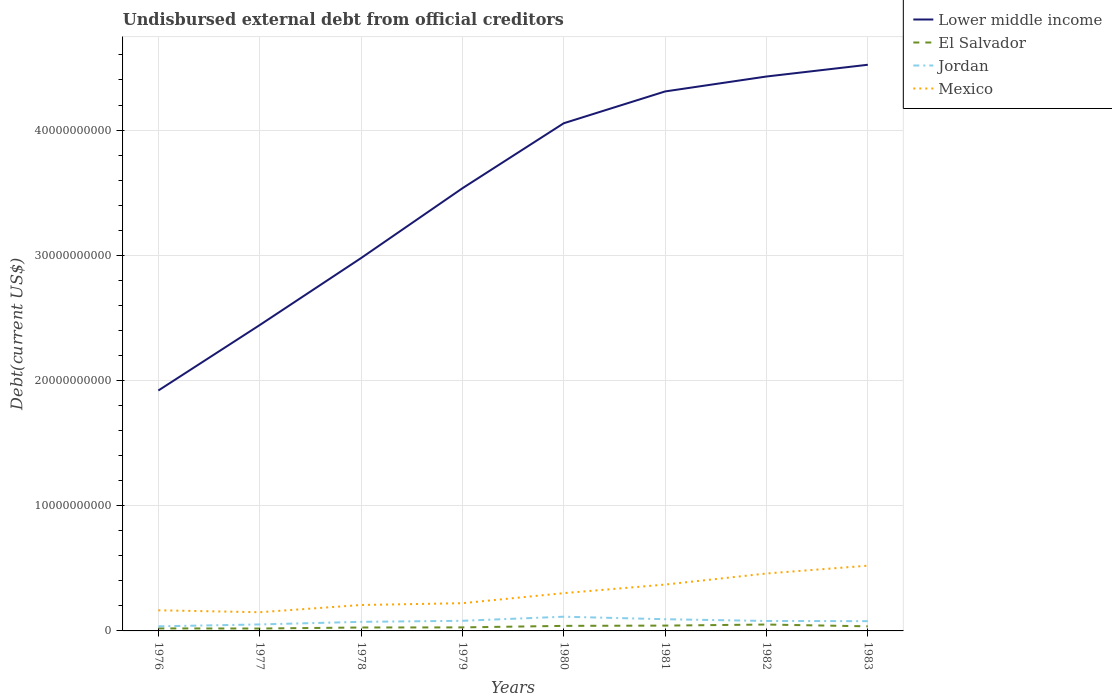How many different coloured lines are there?
Give a very brief answer. 4. Is the number of lines equal to the number of legend labels?
Offer a terse response. Yes. Across all years, what is the maximum total debt in Mexico?
Your answer should be compact. 1.49e+09. In which year was the total debt in Lower middle income maximum?
Ensure brevity in your answer.  1976. What is the total total debt in Lower middle income in the graph?
Make the answer very short. -1.09e+1. What is the difference between the highest and the second highest total debt in Lower middle income?
Provide a succinct answer. 2.60e+1. What is the difference between the highest and the lowest total debt in Lower middle income?
Your response must be concise. 5. How many lines are there?
Offer a terse response. 4. How many years are there in the graph?
Provide a succinct answer. 8. What is the difference between two consecutive major ticks on the Y-axis?
Ensure brevity in your answer.  1.00e+1. Does the graph contain grids?
Your answer should be very brief. Yes. How many legend labels are there?
Ensure brevity in your answer.  4. How are the legend labels stacked?
Offer a very short reply. Vertical. What is the title of the graph?
Give a very brief answer. Undisbursed external debt from official creditors. What is the label or title of the X-axis?
Offer a terse response. Years. What is the label or title of the Y-axis?
Keep it short and to the point. Debt(current US$). What is the Debt(current US$) in Lower middle income in 1976?
Provide a succinct answer. 1.92e+1. What is the Debt(current US$) in El Salvador in 1976?
Offer a terse response. 2.00e+08. What is the Debt(current US$) in Jordan in 1976?
Provide a succinct answer. 3.67e+08. What is the Debt(current US$) in Mexico in 1976?
Keep it short and to the point. 1.65e+09. What is the Debt(current US$) of Lower middle income in 1977?
Your answer should be very brief. 2.44e+1. What is the Debt(current US$) of El Salvador in 1977?
Provide a succinct answer. 1.92e+08. What is the Debt(current US$) in Jordan in 1977?
Provide a short and direct response. 5.18e+08. What is the Debt(current US$) in Mexico in 1977?
Ensure brevity in your answer.  1.49e+09. What is the Debt(current US$) of Lower middle income in 1978?
Your response must be concise. 2.98e+1. What is the Debt(current US$) of El Salvador in 1978?
Your response must be concise. 2.74e+08. What is the Debt(current US$) of Jordan in 1978?
Your response must be concise. 7.25e+08. What is the Debt(current US$) in Mexico in 1978?
Your answer should be compact. 2.07e+09. What is the Debt(current US$) in Lower middle income in 1979?
Provide a short and direct response. 3.54e+1. What is the Debt(current US$) of El Salvador in 1979?
Provide a short and direct response. 2.82e+08. What is the Debt(current US$) of Jordan in 1979?
Keep it short and to the point. 8.08e+08. What is the Debt(current US$) of Mexico in 1979?
Provide a short and direct response. 2.21e+09. What is the Debt(current US$) of Lower middle income in 1980?
Offer a terse response. 4.05e+1. What is the Debt(current US$) in El Salvador in 1980?
Offer a very short reply. 4.03e+08. What is the Debt(current US$) of Jordan in 1980?
Keep it short and to the point. 1.14e+09. What is the Debt(current US$) of Mexico in 1980?
Offer a terse response. 3.02e+09. What is the Debt(current US$) of Lower middle income in 1981?
Make the answer very short. 4.31e+1. What is the Debt(current US$) of El Salvador in 1981?
Provide a short and direct response. 4.26e+08. What is the Debt(current US$) in Jordan in 1981?
Your answer should be very brief. 9.35e+08. What is the Debt(current US$) in Mexico in 1981?
Ensure brevity in your answer.  3.70e+09. What is the Debt(current US$) in Lower middle income in 1982?
Give a very brief answer. 4.43e+1. What is the Debt(current US$) of El Salvador in 1982?
Your answer should be compact. 5.10e+08. What is the Debt(current US$) of Jordan in 1982?
Provide a short and direct response. 7.95e+08. What is the Debt(current US$) of Mexico in 1982?
Make the answer very short. 4.59e+09. What is the Debt(current US$) of Lower middle income in 1983?
Provide a succinct answer. 4.52e+1. What is the Debt(current US$) in El Salvador in 1983?
Ensure brevity in your answer.  3.67e+08. What is the Debt(current US$) in Jordan in 1983?
Provide a succinct answer. 7.79e+08. What is the Debt(current US$) of Mexico in 1983?
Keep it short and to the point. 5.21e+09. Across all years, what is the maximum Debt(current US$) in Lower middle income?
Offer a terse response. 4.52e+1. Across all years, what is the maximum Debt(current US$) in El Salvador?
Your response must be concise. 5.10e+08. Across all years, what is the maximum Debt(current US$) in Jordan?
Your answer should be very brief. 1.14e+09. Across all years, what is the maximum Debt(current US$) of Mexico?
Give a very brief answer. 5.21e+09. Across all years, what is the minimum Debt(current US$) of Lower middle income?
Ensure brevity in your answer.  1.92e+1. Across all years, what is the minimum Debt(current US$) of El Salvador?
Your answer should be compact. 1.92e+08. Across all years, what is the minimum Debt(current US$) in Jordan?
Ensure brevity in your answer.  3.67e+08. Across all years, what is the minimum Debt(current US$) in Mexico?
Ensure brevity in your answer.  1.49e+09. What is the total Debt(current US$) of Lower middle income in the graph?
Your answer should be compact. 2.82e+11. What is the total Debt(current US$) in El Salvador in the graph?
Your response must be concise. 2.65e+09. What is the total Debt(current US$) of Jordan in the graph?
Keep it short and to the point. 6.06e+09. What is the total Debt(current US$) in Mexico in the graph?
Ensure brevity in your answer.  2.39e+1. What is the difference between the Debt(current US$) of Lower middle income in 1976 and that in 1977?
Provide a short and direct response. -5.23e+09. What is the difference between the Debt(current US$) in El Salvador in 1976 and that in 1977?
Offer a terse response. 8.34e+06. What is the difference between the Debt(current US$) in Jordan in 1976 and that in 1977?
Your answer should be very brief. -1.52e+08. What is the difference between the Debt(current US$) in Mexico in 1976 and that in 1977?
Provide a short and direct response. 1.55e+08. What is the difference between the Debt(current US$) in Lower middle income in 1976 and that in 1978?
Your answer should be compact. -1.06e+1. What is the difference between the Debt(current US$) of El Salvador in 1976 and that in 1978?
Your response must be concise. -7.35e+07. What is the difference between the Debt(current US$) of Jordan in 1976 and that in 1978?
Your answer should be very brief. -3.59e+08. What is the difference between the Debt(current US$) of Mexico in 1976 and that in 1978?
Provide a short and direct response. -4.22e+08. What is the difference between the Debt(current US$) of Lower middle income in 1976 and that in 1979?
Offer a very short reply. -1.62e+1. What is the difference between the Debt(current US$) of El Salvador in 1976 and that in 1979?
Make the answer very short. -8.21e+07. What is the difference between the Debt(current US$) of Jordan in 1976 and that in 1979?
Give a very brief answer. -4.42e+08. What is the difference between the Debt(current US$) in Mexico in 1976 and that in 1979?
Make the answer very short. -5.67e+08. What is the difference between the Debt(current US$) in Lower middle income in 1976 and that in 1980?
Offer a terse response. -2.13e+1. What is the difference between the Debt(current US$) of El Salvador in 1976 and that in 1980?
Your response must be concise. -2.03e+08. What is the difference between the Debt(current US$) in Jordan in 1976 and that in 1980?
Your answer should be compact. -7.68e+08. What is the difference between the Debt(current US$) in Mexico in 1976 and that in 1980?
Provide a succinct answer. -1.37e+09. What is the difference between the Debt(current US$) in Lower middle income in 1976 and that in 1981?
Keep it short and to the point. -2.39e+1. What is the difference between the Debt(current US$) in El Salvador in 1976 and that in 1981?
Ensure brevity in your answer.  -2.25e+08. What is the difference between the Debt(current US$) in Jordan in 1976 and that in 1981?
Provide a succinct answer. -5.68e+08. What is the difference between the Debt(current US$) of Mexico in 1976 and that in 1981?
Offer a very short reply. -2.05e+09. What is the difference between the Debt(current US$) of Lower middle income in 1976 and that in 1982?
Ensure brevity in your answer.  -2.51e+1. What is the difference between the Debt(current US$) in El Salvador in 1976 and that in 1982?
Provide a short and direct response. -3.10e+08. What is the difference between the Debt(current US$) in Jordan in 1976 and that in 1982?
Provide a succinct answer. -4.28e+08. What is the difference between the Debt(current US$) in Mexico in 1976 and that in 1982?
Offer a terse response. -2.94e+09. What is the difference between the Debt(current US$) in Lower middle income in 1976 and that in 1983?
Offer a terse response. -2.60e+1. What is the difference between the Debt(current US$) in El Salvador in 1976 and that in 1983?
Give a very brief answer. -1.67e+08. What is the difference between the Debt(current US$) in Jordan in 1976 and that in 1983?
Keep it short and to the point. -4.12e+08. What is the difference between the Debt(current US$) in Mexico in 1976 and that in 1983?
Your response must be concise. -3.56e+09. What is the difference between the Debt(current US$) of Lower middle income in 1977 and that in 1978?
Your response must be concise. -5.35e+09. What is the difference between the Debt(current US$) of El Salvador in 1977 and that in 1978?
Ensure brevity in your answer.  -8.18e+07. What is the difference between the Debt(current US$) in Jordan in 1977 and that in 1978?
Keep it short and to the point. -2.07e+08. What is the difference between the Debt(current US$) in Mexico in 1977 and that in 1978?
Keep it short and to the point. -5.77e+08. What is the difference between the Debt(current US$) in Lower middle income in 1977 and that in 1979?
Offer a very short reply. -1.09e+1. What is the difference between the Debt(current US$) of El Salvador in 1977 and that in 1979?
Your response must be concise. -9.05e+07. What is the difference between the Debt(current US$) of Jordan in 1977 and that in 1979?
Provide a short and direct response. -2.90e+08. What is the difference between the Debt(current US$) of Mexico in 1977 and that in 1979?
Ensure brevity in your answer.  -7.21e+08. What is the difference between the Debt(current US$) of Lower middle income in 1977 and that in 1980?
Ensure brevity in your answer.  -1.61e+1. What is the difference between the Debt(current US$) of El Salvador in 1977 and that in 1980?
Offer a very short reply. -2.11e+08. What is the difference between the Debt(current US$) in Jordan in 1977 and that in 1980?
Offer a terse response. -6.17e+08. What is the difference between the Debt(current US$) of Mexico in 1977 and that in 1980?
Offer a very short reply. -1.52e+09. What is the difference between the Debt(current US$) in Lower middle income in 1977 and that in 1981?
Offer a terse response. -1.87e+1. What is the difference between the Debt(current US$) in El Salvador in 1977 and that in 1981?
Your answer should be compact. -2.34e+08. What is the difference between the Debt(current US$) in Jordan in 1977 and that in 1981?
Your answer should be compact. -4.16e+08. What is the difference between the Debt(current US$) in Mexico in 1977 and that in 1981?
Ensure brevity in your answer.  -2.21e+09. What is the difference between the Debt(current US$) in Lower middle income in 1977 and that in 1982?
Provide a short and direct response. -1.99e+1. What is the difference between the Debt(current US$) in El Salvador in 1977 and that in 1982?
Keep it short and to the point. -3.18e+08. What is the difference between the Debt(current US$) in Jordan in 1977 and that in 1982?
Provide a short and direct response. -2.77e+08. What is the difference between the Debt(current US$) in Mexico in 1977 and that in 1982?
Offer a very short reply. -3.09e+09. What is the difference between the Debt(current US$) of Lower middle income in 1977 and that in 1983?
Offer a very short reply. -2.08e+1. What is the difference between the Debt(current US$) in El Salvador in 1977 and that in 1983?
Keep it short and to the point. -1.75e+08. What is the difference between the Debt(current US$) in Jordan in 1977 and that in 1983?
Provide a short and direct response. -2.61e+08. What is the difference between the Debt(current US$) in Mexico in 1977 and that in 1983?
Your answer should be very brief. -3.72e+09. What is the difference between the Debt(current US$) in Lower middle income in 1978 and that in 1979?
Your response must be concise. -5.58e+09. What is the difference between the Debt(current US$) in El Salvador in 1978 and that in 1979?
Keep it short and to the point. -8.66e+06. What is the difference between the Debt(current US$) of Jordan in 1978 and that in 1979?
Offer a terse response. -8.32e+07. What is the difference between the Debt(current US$) in Mexico in 1978 and that in 1979?
Ensure brevity in your answer.  -1.44e+08. What is the difference between the Debt(current US$) in Lower middle income in 1978 and that in 1980?
Provide a succinct answer. -1.08e+1. What is the difference between the Debt(current US$) of El Salvador in 1978 and that in 1980?
Your answer should be compact. -1.29e+08. What is the difference between the Debt(current US$) of Jordan in 1978 and that in 1980?
Make the answer very short. -4.10e+08. What is the difference between the Debt(current US$) of Mexico in 1978 and that in 1980?
Offer a very short reply. -9.46e+08. What is the difference between the Debt(current US$) of Lower middle income in 1978 and that in 1981?
Provide a short and direct response. -1.33e+1. What is the difference between the Debt(current US$) of El Salvador in 1978 and that in 1981?
Provide a short and direct response. -1.52e+08. What is the difference between the Debt(current US$) of Jordan in 1978 and that in 1981?
Make the answer very short. -2.10e+08. What is the difference between the Debt(current US$) of Mexico in 1978 and that in 1981?
Keep it short and to the point. -1.63e+09. What is the difference between the Debt(current US$) in Lower middle income in 1978 and that in 1982?
Provide a short and direct response. -1.45e+1. What is the difference between the Debt(current US$) of El Salvador in 1978 and that in 1982?
Your response must be concise. -2.37e+08. What is the difference between the Debt(current US$) in Jordan in 1978 and that in 1982?
Your response must be concise. -6.99e+07. What is the difference between the Debt(current US$) in Mexico in 1978 and that in 1982?
Make the answer very short. -2.52e+09. What is the difference between the Debt(current US$) in Lower middle income in 1978 and that in 1983?
Keep it short and to the point. -1.54e+1. What is the difference between the Debt(current US$) in El Salvador in 1978 and that in 1983?
Your answer should be compact. -9.33e+07. What is the difference between the Debt(current US$) in Jordan in 1978 and that in 1983?
Your answer should be very brief. -5.38e+07. What is the difference between the Debt(current US$) in Mexico in 1978 and that in 1983?
Offer a very short reply. -3.14e+09. What is the difference between the Debt(current US$) of Lower middle income in 1979 and that in 1980?
Your answer should be very brief. -5.19e+09. What is the difference between the Debt(current US$) of El Salvador in 1979 and that in 1980?
Provide a short and direct response. -1.21e+08. What is the difference between the Debt(current US$) of Jordan in 1979 and that in 1980?
Provide a succinct answer. -3.27e+08. What is the difference between the Debt(current US$) of Mexico in 1979 and that in 1980?
Your answer should be compact. -8.02e+08. What is the difference between the Debt(current US$) of Lower middle income in 1979 and that in 1981?
Provide a short and direct response. -7.73e+09. What is the difference between the Debt(current US$) of El Salvador in 1979 and that in 1981?
Your answer should be compact. -1.43e+08. What is the difference between the Debt(current US$) in Jordan in 1979 and that in 1981?
Offer a terse response. -1.26e+08. What is the difference between the Debt(current US$) of Mexico in 1979 and that in 1981?
Provide a short and direct response. -1.49e+09. What is the difference between the Debt(current US$) of Lower middle income in 1979 and that in 1982?
Your answer should be very brief. -8.93e+09. What is the difference between the Debt(current US$) of El Salvador in 1979 and that in 1982?
Your answer should be compact. -2.28e+08. What is the difference between the Debt(current US$) of Jordan in 1979 and that in 1982?
Offer a terse response. 1.33e+07. What is the difference between the Debt(current US$) in Mexico in 1979 and that in 1982?
Keep it short and to the point. -2.37e+09. What is the difference between the Debt(current US$) of Lower middle income in 1979 and that in 1983?
Make the answer very short. -9.86e+09. What is the difference between the Debt(current US$) in El Salvador in 1979 and that in 1983?
Provide a short and direct response. -8.46e+07. What is the difference between the Debt(current US$) of Jordan in 1979 and that in 1983?
Offer a very short reply. 2.94e+07. What is the difference between the Debt(current US$) of Mexico in 1979 and that in 1983?
Your answer should be very brief. -3.00e+09. What is the difference between the Debt(current US$) in Lower middle income in 1980 and that in 1981?
Provide a succinct answer. -2.54e+09. What is the difference between the Debt(current US$) in El Salvador in 1980 and that in 1981?
Offer a terse response. -2.24e+07. What is the difference between the Debt(current US$) of Jordan in 1980 and that in 1981?
Offer a terse response. 2.00e+08. What is the difference between the Debt(current US$) in Mexico in 1980 and that in 1981?
Provide a succinct answer. -6.85e+08. What is the difference between the Debt(current US$) of Lower middle income in 1980 and that in 1982?
Your answer should be very brief. -3.73e+09. What is the difference between the Debt(current US$) of El Salvador in 1980 and that in 1982?
Make the answer very short. -1.07e+08. What is the difference between the Debt(current US$) in Jordan in 1980 and that in 1982?
Make the answer very short. 3.40e+08. What is the difference between the Debt(current US$) in Mexico in 1980 and that in 1982?
Provide a short and direct response. -1.57e+09. What is the difference between the Debt(current US$) in Lower middle income in 1980 and that in 1983?
Make the answer very short. -4.67e+09. What is the difference between the Debt(current US$) in El Salvador in 1980 and that in 1983?
Provide a succinct answer. 3.61e+07. What is the difference between the Debt(current US$) of Jordan in 1980 and that in 1983?
Your answer should be very brief. 3.56e+08. What is the difference between the Debt(current US$) of Mexico in 1980 and that in 1983?
Your answer should be compact. -2.19e+09. What is the difference between the Debt(current US$) of Lower middle income in 1981 and that in 1982?
Your answer should be very brief. -1.19e+09. What is the difference between the Debt(current US$) of El Salvador in 1981 and that in 1982?
Your answer should be very brief. -8.48e+07. What is the difference between the Debt(current US$) in Jordan in 1981 and that in 1982?
Ensure brevity in your answer.  1.40e+08. What is the difference between the Debt(current US$) of Mexico in 1981 and that in 1982?
Offer a very short reply. -8.85e+08. What is the difference between the Debt(current US$) in Lower middle income in 1981 and that in 1983?
Provide a succinct answer. -2.13e+09. What is the difference between the Debt(current US$) in El Salvador in 1981 and that in 1983?
Your response must be concise. 5.85e+07. What is the difference between the Debt(current US$) of Jordan in 1981 and that in 1983?
Make the answer very short. 1.56e+08. What is the difference between the Debt(current US$) of Mexico in 1981 and that in 1983?
Your response must be concise. -1.51e+09. What is the difference between the Debt(current US$) in Lower middle income in 1982 and that in 1983?
Offer a terse response. -9.38e+08. What is the difference between the Debt(current US$) of El Salvador in 1982 and that in 1983?
Your response must be concise. 1.43e+08. What is the difference between the Debt(current US$) in Jordan in 1982 and that in 1983?
Your answer should be compact. 1.61e+07. What is the difference between the Debt(current US$) of Mexico in 1982 and that in 1983?
Provide a short and direct response. -6.25e+08. What is the difference between the Debt(current US$) in Lower middle income in 1976 and the Debt(current US$) in El Salvador in 1977?
Offer a terse response. 1.90e+1. What is the difference between the Debt(current US$) in Lower middle income in 1976 and the Debt(current US$) in Jordan in 1977?
Provide a short and direct response. 1.87e+1. What is the difference between the Debt(current US$) of Lower middle income in 1976 and the Debt(current US$) of Mexico in 1977?
Your response must be concise. 1.77e+1. What is the difference between the Debt(current US$) in El Salvador in 1976 and the Debt(current US$) in Jordan in 1977?
Your answer should be very brief. -3.18e+08. What is the difference between the Debt(current US$) of El Salvador in 1976 and the Debt(current US$) of Mexico in 1977?
Give a very brief answer. -1.29e+09. What is the difference between the Debt(current US$) in Jordan in 1976 and the Debt(current US$) in Mexico in 1977?
Offer a very short reply. -1.13e+09. What is the difference between the Debt(current US$) of Lower middle income in 1976 and the Debt(current US$) of El Salvador in 1978?
Provide a short and direct response. 1.89e+1. What is the difference between the Debt(current US$) of Lower middle income in 1976 and the Debt(current US$) of Jordan in 1978?
Offer a very short reply. 1.85e+1. What is the difference between the Debt(current US$) of Lower middle income in 1976 and the Debt(current US$) of Mexico in 1978?
Keep it short and to the point. 1.71e+1. What is the difference between the Debt(current US$) in El Salvador in 1976 and the Debt(current US$) in Jordan in 1978?
Make the answer very short. -5.25e+08. What is the difference between the Debt(current US$) of El Salvador in 1976 and the Debt(current US$) of Mexico in 1978?
Offer a terse response. -1.87e+09. What is the difference between the Debt(current US$) in Jordan in 1976 and the Debt(current US$) in Mexico in 1978?
Your answer should be compact. -1.70e+09. What is the difference between the Debt(current US$) of Lower middle income in 1976 and the Debt(current US$) of El Salvador in 1979?
Your answer should be compact. 1.89e+1. What is the difference between the Debt(current US$) of Lower middle income in 1976 and the Debt(current US$) of Jordan in 1979?
Make the answer very short. 1.84e+1. What is the difference between the Debt(current US$) of Lower middle income in 1976 and the Debt(current US$) of Mexico in 1979?
Make the answer very short. 1.70e+1. What is the difference between the Debt(current US$) in El Salvador in 1976 and the Debt(current US$) in Jordan in 1979?
Ensure brevity in your answer.  -6.08e+08. What is the difference between the Debt(current US$) in El Salvador in 1976 and the Debt(current US$) in Mexico in 1979?
Your answer should be compact. -2.01e+09. What is the difference between the Debt(current US$) in Jordan in 1976 and the Debt(current US$) in Mexico in 1979?
Your response must be concise. -1.85e+09. What is the difference between the Debt(current US$) of Lower middle income in 1976 and the Debt(current US$) of El Salvador in 1980?
Ensure brevity in your answer.  1.88e+1. What is the difference between the Debt(current US$) of Lower middle income in 1976 and the Debt(current US$) of Jordan in 1980?
Offer a terse response. 1.81e+1. What is the difference between the Debt(current US$) in Lower middle income in 1976 and the Debt(current US$) in Mexico in 1980?
Make the answer very short. 1.62e+1. What is the difference between the Debt(current US$) of El Salvador in 1976 and the Debt(current US$) of Jordan in 1980?
Keep it short and to the point. -9.35e+08. What is the difference between the Debt(current US$) in El Salvador in 1976 and the Debt(current US$) in Mexico in 1980?
Make the answer very short. -2.82e+09. What is the difference between the Debt(current US$) in Jordan in 1976 and the Debt(current US$) in Mexico in 1980?
Keep it short and to the point. -2.65e+09. What is the difference between the Debt(current US$) in Lower middle income in 1976 and the Debt(current US$) in El Salvador in 1981?
Offer a terse response. 1.88e+1. What is the difference between the Debt(current US$) of Lower middle income in 1976 and the Debt(current US$) of Jordan in 1981?
Provide a succinct answer. 1.83e+1. What is the difference between the Debt(current US$) of Lower middle income in 1976 and the Debt(current US$) of Mexico in 1981?
Provide a succinct answer. 1.55e+1. What is the difference between the Debt(current US$) in El Salvador in 1976 and the Debt(current US$) in Jordan in 1981?
Keep it short and to the point. -7.35e+08. What is the difference between the Debt(current US$) of El Salvador in 1976 and the Debt(current US$) of Mexico in 1981?
Provide a succinct answer. -3.50e+09. What is the difference between the Debt(current US$) in Jordan in 1976 and the Debt(current US$) in Mexico in 1981?
Your response must be concise. -3.33e+09. What is the difference between the Debt(current US$) in Lower middle income in 1976 and the Debt(current US$) in El Salvador in 1982?
Offer a very short reply. 1.87e+1. What is the difference between the Debt(current US$) in Lower middle income in 1976 and the Debt(current US$) in Jordan in 1982?
Provide a short and direct response. 1.84e+1. What is the difference between the Debt(current US$) in Lower middle income in 1976 and the Debt(current US$) in Mexico in 1982?
Make the answer very short. 1.46e+1. What is the difference between the Debt(current US$) in El Salvador in 1976 and the Debt(current US$) in Jordan in 1982?
Provide a succinct answer. -5.95e+08. What is the difference between the Debt(current US$) in El Salvador in 1976 and the Debt(current US$) in Mexico in 1982?
Keep it short and to the point. -4.39e+09. What is the difference between the Debt(current US$) in Jordan in 1976 and the Debt(current US$) in Mexico in 1982?
Keep it short and to the point. -4.22e+09. What is the difference between the Debt(current US$) in Lower middle income in 1976 and the Debt(current US$) in El Salvador in 1983?
Offer a terse response. 1.88e+1. What is the difference between the Debt(current US$) in Lower middle income in 1976 and the Debt(current US$) in Jordan in 1983?
Offer a very short reply. 1.84e+1. What is the difference between the Debt(current US$) in Lower middle income in 1976 and the Debt(current US$) in Mexico in 1983?
Your answer should be compact. 1.40e+1. What is the difference between the Debt(current US$) in El Salvador in 1976 and the Debt(current US$) in Jordan in 1983?
Your response must be concise. -5.79e+08. What is the difference between the Debt(current US$) of El Salvador in 1976 and the Debt(current US$) of Mexico in 1983?
Offer a terse response. -5.01e+09. What is the difference between the Debt(current US$) in Jordan in 1976 and the Debt(current US$) in Mexico in 1983?
Ensure brevity in your answer.  -4.84e+09. What is the difference between the Debt(current US$) of Lower middle income in 1977 and the Debt(current US$) of El Salvador in 1978?
Keep it short and to the point. 2.42e+1. What is the difference between the Debt(current US$) in Lower middle income in 1977 and the Debt(current US$) in Jordan in 1978?
Make the answer very short. 2.37e+1. What is the difference between the Debt(current US$) in Lower middle income in 1977 and the Debt(current US$) in Mexico in 1978?
Your answer should be very brief. 2.24e+1. What is the difference between the Debt(current US$) of El Salvador in 1977 and the Debt(current US$) of Jordan in 1978?
Your answer should be compact. -5.33e+08. What is the difference between the Debt(current US$) in El Salvador in 1977 and the Debt(current US$) in Mexico in 1978?
Make the answer very short. -1.88e+09. What is the difference between the Debt(current US$) of Jordan in 1977 and the Debt(current US$) of Mexico in 1978?
Your answer should be compact. -1.55e+09. What is the difference between the Debt(current US$) of Lower middle income in 1977 and the Debt(current US$) of El Salvador in 1979?
Your answer should be compact. 2.41e+1. What is the difference between the Debt(current US$) in Lower middle income in 1977 and the Debt(current US$) in Jordan in 1979?
Your response must be concise. 2.36e+1. What is the difference between the Debt(current US$) in Lower middle income in 1977 and the Debt(current US$) in Mexico in 1979?
Your answer should be very brief. 2.22e+1. What is the difference between the Debt(current US$) of El Salvador in 1977 and the Debt(current US$) of Jordan in 1979?
Make the answer very short. -6.17e+08. What is the difference between the Debt(current US$) of El Salvador in 1977 and the Debt(current US$) of Mexico in 1979?
Keep it short and to the point. -2.02e+09. What is the difference between the Debt(current US$) of Jordan in 1977 and the Debt(current US$) of Mexico in 1979?
Ensure brevity in your answer.  -1.70e+09. What is the difference between the Debt(current US$) of Lower middle income in 1977 and the Debt(current US$) of El Salvador in 1980?
Give a very brief answer. 2.40e+1. What is the difference between the Debt(current US$) of Lower middle income in 1977 and the Debt(current US$) of Jordan in 1980?
Provide a succinct answer. 2.33e+1. What is the difference between the Debt(current US$) in Lower middle income in 1977 and the Debt(current US$) in Mexico in 1980?
Ensure brevity in your answer.  2.14e+1. What is the difference between the Debt(current US$) of El Salvador in 1977 and the Debt(current US$) of Jordan in 1980?
Make the answer very short. -9.43e+08. What is the difference between the Debt(current US$) of El Salvador in 1977 and the Debt(current US$) of Mexico in 1980?
Ensure brevity in your answer.  -2.82e+09. What is the difference between the Debt(current US$) of Jordan in 1977 and the Debt(current US$) of Mexico in 1980?
Your answer should be very brief. -2.50e+09. What is the difference between the Debt(current US$) in Lower middle income in 1977 and the Debt(current US$) in El Salvador in 1981?
Give a very brief answer. 2.40e+1. What is the difference between the Debt(current US$) of Lower middle income in 1977 and the Debt(current US$) of Jordan in 1981?
Your response must be concise. 2.35e+1. What is the difference between the Debt(current US$) in Lower middle income in 1977 and the Debt(current US$) in Mexico in 1981?
Provide a short and direct response. 2.07e+1. What is the difference between the Debt(current US$) of El Salvador in 1977 and the Debt(current US$) of Jordan in 1981?
Provide a short and direct response. -7.43e+08. What is the difference between the Debt(current US$) of El Salvador in 1977 and the Debt(current US$) of Mexico in 1981?
Ensure brevity in your answer.  -3.51e+09. What is the difference between the Debt(current US$) of Jordan in 1977 and the Debt(current US$) of Mexico in 1981?
Provide a short and direct response. -3.18e+09. What is the difference between the Debt(current US$) of Lower middle income in 1977 and the Debt(current US$) of El Salvador in 1982?
Make the answer very short. 2.39e+1. What is the difference between the Debt(current US$) of Lower middle income in 1977 and the Debt(current US$) of Jordan in 1982?
Your answer should be compact. 2.36e+1. What is the difference between the Debt(current US$) in Lower middle income in 1977 and the Debt(current US$) in Mexico in 1982?
Provide a succinct answer. 1.98e+1. What is the difference between the Debt(current US$) of El Salvador in 1977 and the Debt(current US$) of Jordan in 1982?
Make the answer very short. -6.03e+08. What is the difference between the Debt(current US$) in El Salvador in 1977 and the Debt(current US$) in Mexico in 1982?
Provide a succinct answer. -4.39e+09. What is the difference between the Debt(current US$) in Jordan in 1977 and the Debt(current US$) in Mexico in 1982?
Your answer should be compact. -4.07e+09. What is the difference between the Debt(current US$) in Lower middle income in 1977 and the Debt(current US$) in El Salvador in 1983?
Provide a succinct answer. 2.41e+1. What is the difference between the Debt(current US$) of Lower middle income in 1977 and the Debt(current US$) of Jordan in 1983?
Keep it short and to the point. 2.36e+1. What is the difference between the Debt(current US$) of Lower middle income in 1977 and the Debt(current US$) of Mexico in 1983?
Keep it short and to the point. 1.92e+1. What is the difference between the Debt(current US$) in El Salvador in 1977 and the Debt(current US$) in Jordan in 1983?
Provide a succinct answer. -5.87e+08. What is the difference between the Debt(current US$) in El Salvador in 1977 and the Debt(current US$) in Mexico in 1983?
Ensure brevity in your answer.  -5.02e+09. What is the difference between the Debt(current US$) of Jordan in 1977 and the Debt(current US$) of Mexico in 1983?
Offer a very short reply. -4.69e+09. What is the difference between the Debt(current US$) of Lower middle income in 1978 and the Debt(current US$) of El Salvador in 1979?
Your response must be concise. 2.95e+1. What is the difference between the Debt(current US$) of Lower middle income in 1978 and the Debt(current US$) of Jordan in 1979?
Provide a succinct answer. 2.90e+1. What is the difference between the Debt(current US$) of Lower middle income in 1978 and the Debt(current US$) of Mexico in 1979?
Provide a succinct answer. 2.76e+1. What is the difference between the Debt(current US$) of El Salvador in 1978 and the Debt(current US$) of Jordan in 1979?
Make the answer very short. -5.35e+08. What is the difference between the Debt(current US$) in El Salvador in 1978 and the Debt(current US$) in Mexico in 1979?
Provide a succinct answer. -1.94e+09. What is the difference between the Debt(current US$) of Jordan in 1978 and the Debt(current US$) of Mexico in 1979?
Your answer should be compact. -1.49e+09. What is the difference between the Debt(current US$) in Lower middle income in 1978 and the Debt(current US$) in El Salvador in 1980?
Give a very brief answer. 2.94e+1. What is the difference between the Debt(current US$) in Lower middle income in 1978 and the Debt(current US$) in Jordan in 1980?
Provide a succinct answer. 2.86e+1. What is the difference between the Debt(current US$) of Lower middle income in 1978 and the Debt(current US$) of Mexico in 1980?
Offer a very short reply. 2.68e+1. What is the difference between the Debt(current US$) of El Salvador in 1978 and the Debt(current US$) of Jordan in 1980?
Your answer should be compact. -8.61e+08. What is the difference between the Debt(current US$) in El Salvador in 1978 and the Debt(current US$) in Mexico in 1980?
Provide a succinct answer. -2.74e+09. What is the difference between the Debt(current US$) in Jordan in 1978 and the Debt(current US$) in Mexico in 1980?
Offer a very short reply. -2.29e+09. What is the difference between the Debt(current US$) in Lower middle income in 1978 and the Debt(current US$) in El Salvador in 1981?
Offer a terse response. 2.94e+1. What is the difference between the Debt(current US$) of Lower middle income in 1978 and the Debt(current US$) of Jordan in 1981?
Your answer should be very brief. 2.88e+1. What is the difference between the Debt(current US$) of Lower middle income in 1978 and the Debt(current US$) of Mexico in 1981?
Provide a succinct answer. 2.61e+1. What is the difference between the Debt(current US$) in El Salvador in 1978 and the Debt(current US$) in Jordan in 1981?
Your answer should be very brief. -6.61e+08. What is the difference between the Debt(current US$) in El Salvador in 1978 and the Debt(current US$) in Mexico in 1981?
Provide a succinct answer. -3.43e+09. What is the difference between the Debt(current US$) of Jordan in 1978 and the Debt(current US$) of Mexico in 1981?
Offer a terse response. -2.98e+09. What is the difference between the Debt(current US$) of Lower middle income in 1978 and the Debt(current US$) of El Salvador in 1982?
Provide a succinct answer. 2.93e+1. What is the difference between the Debt(current US$) in Lower middle income in 1978 and the Debt(current US$) in Jordan in 1982?
Your answer should be compact. 2.90e+1. What is the difference between the Debt(current US$) in Lower middle income in 1978 and the Debt(current US$) in Mexico in 1982?
Give a very brief answer. 2.52e+1. What is the difference between the Debt(current US$) in El Salvador in 1978 and the Debt(current US$) in Jordan in 1982?
Provide a short and direct response. -5.21e+08. What is the difference between the Debt(current US$) in El Salvador in 1978 and the Debt(current US$) in Mexico in 1982?
Keep it short and to the point. -4.31e+09. What is the difference between the Debt(current US$) of Jordan in 1978 and the Debt(current US$) of Mexico in 1982?
Give a very brief answer. -3.86e+09. What is the difference between the Debt(current US$) of Lower middle income in 1978 and the Debt(current US$) of El Salvador in 1983?
Your answer should be compact. 2.94e+1. What is the difference between the Debt(current US$) in Lower middle income in 1978 and the Debt(current US$) in Jordan in 1983?
Ensure brevity in your answer.  2.90e+1. What is the difference between the Debt(current US$) of Lower middle income in 1978 and the Debt(current US$) of Mexico in 1983?
Your answer should be compact. 2.46e+1. What is the difference between the Debt(current US$) in El Salvador in 1978 and the Debt(current US$) in Jordan in 1983?
Offer a very short reply. -5.05e+08. What is the difference between the Debt(current US$) of El Salvador in 1978 and the Debt(current US$) of Mexico in 1983?
Your response must be concise. -4.94e+09. What is the difference between the Debt(current US$) of Jordan in 1978 and the Debt(current US$) of Mexico in 1983?
Provide a succinct answer. -4.49e+09. What is the difference between the Debt(current US$) of Lower middle income in 1979 and the Debt(current US$) of El Salvador in 1980?
Provide a short and direct response. 3.49e+1. What is the difference between the Debt(current US$) of Lower middle income in 1979 and the Debt(current US$) of Jordan in 1980?
Provide a short and direct response. 3.42e+1. What is the difference between the Debt(current US$) in Lower middle income in 1979 and the Debt(current US$) in Mexico in 1980?
Your answer should be compact. 3.23e+1. What is the difference between the Debt(current US$) in El Salvador in 1979 and the Debt(current US$) in Jordan in 1980?
Your answer should be compact. -8.53e+08. What is the difference between the Debt(current US$) in El Salvador in 1979 and the Debt(current US$) in Mexico in 1980?
Your response must be concise. -2.73e+09. What is the difference between the Debt(current US$) of Jordan in 1979 and the Debt(current US$) of Mexico in 1980?
Offer a terse response. -2.21e+09. What is the difference between the Debt(current US$) of Lower middle income in 1979 and the Debt(current US$) of El Salvador in 1981?
Ensure brevity in your answer.  3.49e+1. What is the difference between the Debt(current US$) of Lower middle income in 1979 and the Debt(current US$) of Jordan in 1981?
Your answer should be very brief. 3.44e+1. What is the difference between the Debt(current US$) of Lower middle income in 1979 and the Debt(current US$) of Mexico in 1981?
Keep it short and to the point. 3.17e+1. What is the difference between the Debt(current US$) in El Salvador in 1979 and the Debt(current US$) in Jordan in 1981?
Your response must be concise. -6.52e+08. What is the difference between the Debt(current US$) in El Salvador in 1979 and the Debt(current US$) in Mexico in 1981?
Your answer should be compact. -3.42e+09. What is the difference between the Debt(current US$) in Jordan in 1979 and the Debt(current US$) in Mexico in 1981?
Keep it short and to the point. -2.89e+09. What is the difference between the Debt(current US$) in Lower middle income in 1979 and the Debt(current US$) in El Salvador in 1982?
Offer a very short reply. 3.48e+1. What is the difference between the Debt(current US$) of Lower middle income in 1979 and the Debt(current US$) of Jordan in 1982?
Your answer should be very brief. 3.46e+1. What is the difference between the Debt(current US$) of Lower middle income in 1979 and the Debt(current US$) of Mexico in 1982?
Offer a terse response. 3.08e+1. What is the difference between the Debt(current US$) in El Salvador in 1979 and the Debt(current US$) in Jordan in 1982?
Keep it short and to the point. -5.13e+08. What is the difference between the Debt(current US$) in El Salvador in 1979 and the Debt(current US$) in Mexico in 1982?
Your answer should be compact. -4.30e+09. What is the difference between the Debt(current US$) in Jordan in 1979 and the Debt(current US$) in Mexico in 1982?
Make the answer very short. -3.78e+09. What is the difference between the Debt(current US$) of Lower middle income in 1979 and the Debt(current US$) of El Salvador in 1983?
Offer a terse response. 3.50e+1. What is the difference between the Debt(current US$) in Lower middle income in 1979 and the Debt(current US$) in Jordan in 1983?
Make the answer very short. 3.46e+1. What is the difference between the Debt(current US$) in Lower middle income in 1979 and the Debt(current US$) in Mexico in 1983?
Offer a terse response. 3.01e+1. What is the difference between the Debt(current US$) in El Salvador in 1979 and the Debt(current US$) in Jordan in 1983?
Keep it short and to the point. -4.97e+08. What is the difference between the Debt(current US$) of El Salvador in 1979 and the Debt(current US$) of Mexico in 1983?
Ensure brevity in your answer.  -4.93e+09. What is the difference between the Debt(current US$) in Jordan in 1979 and the Debt(current US$) in Mexico in 1983?
Keep it short and to the point. -4.40e+09. What is the difference between the Debt(current US$) of Lower middle income in 1980 and the Debt(current US$) of El Salvador in 1981?
Provide a short and direct response. 4.01e+1. What is the difference between the Debt(current US$) in Lower middle income in 1980 and the Debt(current US$) in Jordan in 1981?
Your answer should be very brief. 3.96e+1. What is the difference between the Debt(current US$) in Lower middle income in 1980 and the Debt(current US$) in Mexico in 1981?
Offer a very short reply. 3.68e+1. What is the difference between the Debt(current US$) of El Salvador in 1980 and the Debt(current US$) of Jordan in 1981?
Ensure brevity in your answer.  -5.32e+08. What is the difference between the Debt(current US$) of El Salvador in 1980 and the Debt(current US$) of Mexico in 1981?
Your response must be concise. -3.30e+09. What is the difference between the Debt(current US$) in Jordan in 1980 and the Debt(current US$) in Mexico in 1981?
Ensure brevity in your answer.  -2.57e+09. What is the difference between the Debt(current US$) in Lower middle income in 1980 and the Debt(current US$) in El Salvador in 1982?
Provide a short and direct response. 4.00e+1. What is the difference between the Debt(current US$) of Lower middle income in 1980 and the Debt(current US$) of Jordan in 1982?
Ensure brevity in your answer.  3.98e+1. What is the difference between the Debt(current US$) in Lower middle income in 1980 and the Debt(current US$) in Mexico in 1982?
Provide a short and direct response. 3.60e+1. What is the difference between the Debt(current US$) in El Salvador in 1980 and the Debt(current US$) in Jordan in 1982?
Provide a short and direct response. -3.92e+08. What is the difference between the Debt(current US$) in El Salvador in 1980 and the Debt(current US$) in Mexico in 1982?
Keep it short and to the point. -4.18e+09. What is the difference between the Debt(current US$) in Jordan in 1980 and the Debt(current US$) in Mexico in 1982?
Your answer should be very brief. -3.45e+09. What is the difference between the Debt(current US$) of Lower middle income in 1980 and the Debt(current US$) of El Salvador in 1983?
Keep it short and to the point. 4.02e+1. What is the difference between the Debt(current US$) in Lower middle income in 1980 and the Debt(current US$) in Jordan in 1983?
Your answer should be compact. 3.98e+1. What is the difference between the Debt(current US$) of Lower middle income in 1980 and the Debt(current US$) of Mexico in 1983?
Provide a succinct answer. 3.53e+1. What is the difference between the Debt(current US$) of El Salvador in 1980 and the Debt(current US$) of Jordan in 1983?
Offer a terse response. -3.76e+08. What is the difference between the Debt(current US$) of El Salvador in 1980 and the Debt(current US$) of Mexico in 1983?
Your answer should be compact. -4.81e+09. What is the difference between the Debt(current US$) of Jordan in 1980 and the Debt(current US$) of Mexico in 1983?
Keep it short and to the point. -4.08e+09. What is the difference between the Debt(current US$) of Lower middle income in 1981 and the Debt(current US$) of El Salvador in 1982?
Provide a short and direct response. 4.26e+1. What is the difference between the Debt(current US$) in Lower middle income in 1981 and the Debt(current US$) in Jordan in 1982?
Ensure brevity in your answer.  4.23e+1. What is the difference between the Debt(current US$) in Lower middle income in 1981 and the Debt(current US$) in Mexico in 1982?
Offer a terse response. 3.85e+1. What is the difference between the Debt(current US$) of El Salvador in 1981 and the Debt(current US$) of Jordan in 1982?
Give a very brief answer. -3.70e+08. What is the difference between the Debt(current US$) in El Salvador in 1981 and the Debt(current US$) in Mexico in 1982?
Your response must be concise. -4.16e+09. What is the difference between the Debt(current US$) of Jordan in 1981 and the Debt(current US$) of Mexico in 1982?
Your response must be concise. -3.65e+09. What is the difference between the Debt(current US$) in Lower middle income in 1981 and the Debt(current US$) in El Salvador in 1983?
Give a very brief answer. 4.27e+1. What is the difference between the Debt(current US$) of Lower middle income in 1981 and the Debt(current US$) of Jordan in 1983?
Your response must be concise. 4.23e+1. What is the difference between the Debt(current US$) of Lower middle income in 1981 and the Debt(current US$) of Mexico in 1983?
Provide a short and direct response. 3.79e+1. What is the difference between the Debt(current US$) of El Salvador in 1981 and the Debt(current US$) of Jordan in 1983?
Your answer should be very brief. -3.54e+08. What is the difference between the Debt(current US$) of El Salvador in 1981 and the Debt(current US$) of Mexico in 1983?
Provide a succinct answer. -4.79e+09. What is the difference between the Debt(current US$) in Jordan in 1981 and the Debt(current US$) in Mexico in 1983?
Keep it short and to the point. -4.28e+09. What is the difference between the Debt(current US$) in Lower middle income in 1982 and the Debt(current US$) in El Salvador in 1983?
Keep it short and to the point. 4.39e+1. What is the difference between the Debt(current US$) in Lower middle income in 1982 and the Debt(current US$) in Jordan in 1983?
Your answer should be compact. 4.35e+1. What is the difference between the Debt(current US$) of Lower middle income in 1982 and the Debt(current US$) of Mexico in 1983?
Make the answer very short. 3.91e+1. What is the difference between the Debt(current US$) of El Salvador in 1982 and the Debt(current US$) of Jordan in 1983?
Keep it short and to the point. -2.69e+08. What is the difference between the Debt(current US$) of El Salvador in 1982 and the Debt(current US$) of Mexico in 1983?
Provide a short and direct response. -4.70e+09. What is the difference between the Debt(current US$) in Jordan in 1982 and the Debt(current US$) in Mexico in 1983?
Your answer should be very brief. -4.42e+09. What is the average Debt(current US$) of Lower middle income per year?
Make the answer very short. 3.52e+1. What is the average Debt(current US$) of El Salvador per year?
Offer a very short reply. 3.32e+08. What is the average Debt(current US$) of Jordan per year?
Ensure brevity in your answer.  7.58e+08. What is the average Debt(current US$) of Mexico per year?
Offer a terse response. 2.99e+09. In the year 1976, what is the difference between the Debt(current US$) of Lower middle income and Debt(current US$) of El Salvador?
Provide a short and direct response. 1.90e+1. In the year 1976, what is the difference between the Debt(current US$) of Lower middle income and Debt(current US$) of Jordan?
Your response must be concise. 1.88e+1. In the year 1976, what is the difference between the Debt(current US$) in Lower middle income and Debt(current US$) in Mexico?
Ensure brevity in your answer.  1.76e+1. In the year 1976, what is the difference between the Debt(current US$) of El Salvador and Debt(current US$) of Jordan?
Provide a short and direct response. -1.67e+08. In the year 1976, what is the difference between the Debt(current US$) in El Salvador and Debt(current US$) in Mexico?
Your answer should be compact. -1.45e+09. In the year 1976, what is the difference between the Debt(current US$) of Jordan and Debt(current US$) of Mexico?
Give a very brief answer. -1.28e+09. In the year 1977, what is the difference between the Debt(current US$) in Lower middle income and Debt(current US$) in El Salvador?
Your answer should be very brief. 2.42e+1. In the year 1977, what is the difference between the Debt(current US$) of Lower middle income and Debt(current US$) of Jordan?
Your response must be concise. 2.39e+1. In the year 1977, what is the difference between the Debt(current US$) in Lower middle income and Debt(current US$) in Mexico?
Your answer should be very brief. 2.29e+1. In the year 1977, what is the difference between the Debt(current US$) of El Salvador and Debt(current US$) of Jordan?
Offer a terse response. -3.27e+08. In the year 1977, what is the difference between the Debt(current US$) in El Salvador and Debt(current US$) in Mexico?
Your response must be concise. -1.30e+09. In the year 1977, what is the difference between the Debt(current US$) of Jordan and Debt(current US$) of Mexico?
Ensure brevity in your answer.  -9.74e+08. In the year 1978, what is the difference between the Debt(current US$) in Lower middle income and Debt(current US$) in El Salvador?
Your response must be concise. 2.95e+1. In the year 1978, what is the difference between the Debt(current US$) of Lower middle income and Debt(current US$) of Jordan?
Give a very brief answer. 2.91e+1. In the year 1978, what is the difference between the Debt(current US$) in Lower middle income and Debt(current US$) in Mexico?
Your answer should be very brief. 2.77e+1. In the year 1978, what is the difference between the Debt(current US$) of El Salvador and Debt(current US$) of Jordan?
Your answer should be compact. -4.52e+08. In the year 1978, what is the difference between the Debt(current US$) in El Salvador and Debt(current US$) in Mexico?
Your answer should be compact. -1.80e+09. In the year 1978, what is the difference between the Debt(current US$) of Jordan and Debt(current US$) of Mexico?
Your answer should be very brief. -1.34e+09. In the year 1979, what is the difference between the Debt(current US$) in Lower middle income and Debt(current US$) in El Salvador?
Offer a terse response. 3.51e+1. In the year 1979, what is the difference between the Debt(current US$) in Lower middle income and Debt(current US$) in Jordan?
Offer a very short reply. 3.45e+1. In the year 1979, what is the difference between the Debt(current US$) in Lower middle income and Debt(current US$) in Mexico?
Offer a very short reply. 3.31e+1. In the year 1979, what is the difference between the Debt(current US$) of El Salvador and Debt(current US$) of Jordan?
Ensure brevity in your answer.  -5.26e+08. In the year 1979, what is the difference between the Debt(current US$) of El Salvador and Debt(current US$) of Mexico?
Your answer should be compact. -1.93e+09. In the year 1979, what is the difference between the Debt(current US$) of Jordan and Debt(current US$) of Mexico?
Provide a succinct answer. -1.41e+09. In the year 1980, what is the difference between the Debt(current US$) in Lower middle income and Debt(current US$) in El Salvador?
Your answer should be compact. 4.01e+1. In the year 1980, what is the difference between the Debt(current US$) in Lower middle income and Debt(current US$) in Jordan?
Provide a short and direct response. 3.94e+1. In the year 1980, what is the difference between the Debt(current US$) in Lower middle income and Debt(current US$) in Mexico?
Your answer should be very brief. 3.75e+1. In the year 1980, what is the difference between the Debt(current US$) of El Salvador and Debt(current US$) of Jordan?
Offer a very short reply. -7.32e+08. In the year 1980, what is the difference between the Debt(current US$) of El Salvador and Debt(current US$) of Mexico?
Your answer should be very brief. -2.61e+09. In the year 1980, what is the difference between the Debt(current US$) in Jordan and Debt(current US$) in Mexico?
Make the answer very short. -1.88e+09. In the year 1981, what is the difference between the Debt(current US$) of Lower middle income and Debt(current US$) of El Salvador?
Your answer should be very brief. 4.27e+1. In the year 1981, what is the difference between the Debt(current US$) in Lower middle income and Debt(current US$) in Jordan?
Your response must be concise. 4.22e+1. In the year 1981, what is the difference between the Debt(current US$) in Lower middle income and Debt(current US$) in Mexico?
Offer a terse response. 3.94e+1. In the year 1981, what is the difference between the Debt(current US$) of El Salvador and Debt(current US$) of Jordan?
Offer a terse response. -5.09e+08. In the year 1981, what is the difference between the Debt(current US$) in El Salvador and Debt(current US$) in Mexico?
Your answer should be compact. -3.28e+09. In the year 1981, what is the difference between the Debt(current US$) of Jordan and Debt(current US$) of Mexico?
Offer a very short reply. -2.77e+09. In the year 1982, what is the difference between the Debt(current US$) of Lower middle income and Debt(current US$) of El Salvador?
Your answer should be compact. 4.38e+1. In the year 1982, what is the difference between the Debt(current US$) in Lower middle income and Debt(current US$) in Jordan?
Provide a short and direct response. 4.35e+1. In the year 1982, what is the difference between the Debt(current US$) in Lower middle income and Debt(current US$) in Mexico?
Provide a short and direct response. 3.97e+1. In the year 1982, what is the difference between the Debt(current US$) in El Salvador and Debt(current US$) in Jordan?
Your response must be concise. -2.85e+08. In the year 1982, what is the difference between the Debt(current US$) in El Salvador and Debt(current US$) in Mexico?
Your answer should be compact. -4.08e+09. In the year 1982, what is the difference between the Debt(current US$) in Jordan and Debt(current US$) in Mexico?
Provide a short and direct response. -3.79e+09. In the year 1983, what is the difference between the Debt(current US$) of Lower middle income and Debt(current US$) of El Salvador?
Provide a succinct answer. 4.48e+1. In the year 1983, what is the difference between the Debt(current US$) in Lower middle income and Debt(current US$) in Jordan?
Your answer should be compact. 4.44e+1. In the year 1983, what is the difference between the Debt(current US$) in Lower middle income and Debt(current US$) in Mexico?
Make the answer very short. 4.00e+1. In the year 1983, what is the difference between the Debt(current US$) of El Salvador and Debt(current US$) of Jordan?
Your answer should be compact. -4.12e+08. In the year 1983, what is the difference between the Debt(current US$) of El Salvador and Debt(current US$) of Mexico?
Offer a terse response. -4.84e+09. In the year 1983, what is the difference between the Debt(current US$) of Jordan and Debt(current US$) of Mexico?
Your response must be concise. -4.43e+09. What is the ratio of the Debt(current US$) in Lower middle income in 1976 to that in 1977?
Your answer should be very brief. 0.79. What is the ratio of the Debt(current US$) of El Salvador in 1976 to that in 1977?
Keep it short and to the point. 1.04. What is the ratio of the Debt(current US$) of Jordan in 1976 to that in 1977?
Offer a very short reply. 0.71. What is the ratio of the Debt(current US$) of Mexico in 1976 to that in 1977?
Your answer should be compact. 1.1. What is the ratio of the Debt(current US$) in Lower middle income in 1976 to that in 1978?
Ensure brevity in your answer.  0.64. What is the ratio of the Debt(current US$) in El Salvador in 1976 to that in 1978?
Offer a very short reply. 0.73. What is the ratio of the Debt(current US$) of Jordan in 1976 to that in 1978?
Your answer should be very brief. 0.51. What is the ratio of the Debt(current US$) in Mexico in 1976 to that in 1978?
Your answer should be compact. 0.8. What is the ratio of the Debt(current US$) in Lower middle income in 1976 to that in 1979?
Your response must be concise. 0.54. What is the ratio of the Debt(current US$) in El Salvador in 1976 to that in 1979?
Make the answer very short. 0.71. What is the ratio of the Debt(current US$) of Jordan in 1976 to that in 1979?
Ensure brevity in your answer.  0.45. What is the ratio of the Debt(current US$) in Mexico in 1976 to that in 1979?
Your answer should be compact. 0.74. What is the ratio of the Debt(current US$) of Lower middle income in 1976 to that in 1980?
Make the answer very short. 0.47. What is the ratio of the Debt(current US$) in El Salvador in 1976 to that in 1980?
Your answer should be compact. 0.5. What is the ratio of the Debt(current US$) in Jordan in 1976 to that in 1980?
Offer a very short reply. 0.32. What is the ratio of the Debt(current US$) of Mexico in 1976 to that in 1980?
Provide a short and direct response. 0.55. What is the ratio of the Debt(current US$) of Lower middle income in 1976 to that in 1981?
Your answer should be compact. 0.45. What is the ratio of the Debt(current US$) of El Salvador in 1976 to that in 1981?
Make the answer very short. 0.47. What is the ratio of the Debt(current US$) in Jordan in 1976 to that in 1981?
Give a very brief answer. 0.39. What is the ratio of the Debt(current US$) in Mexico in 1976 to that in 1981?
Offer a terse response. 0.45. What is the ratio of the Debt(current US$) in Lower middle income in 1976 to that in 1982?
Ensure brevity in your answer.  0.43. What is the ratio of the Debt(current US$) of El Salvador in 1976 to that in 1982?
Provide a succinct answer. 0.39. What is the ratio of the Debt(current US$) in Jordan in 1976 to that in 1982?
Provide a short and direct response. 0.46. What is the ratio of the Debt(current US$) in Mexico in 1976 to that in 1982?
Offer a very short reply. 0.36. What is the ratio of the Debt(current US$) of Lower middle income in 1976 to that in 1983?
Make the answer very short. 0.42. What is the ratio of the Debt(current US$) in El Salvador in 1976 to that in 1983?
Give a very brief answer. 0.55. What is the ratio of the Debt(current US$) in Jordan in 1976 to that in 1983?
Your response must be concise. 0.47. What is the ratio of the Debt(current US$) of Mexico in 1976 to that in 1983?
Provide a short and direct response. 0.32. What is the ratio of the Debt(current US$) of Lower middle income in 1977 to that in 1978?
Provide a short and direct response. 0.82. What is the ratio of the Debt(current US$) of El Salvador in 1977 to that in 1978?
Provide a succinct answer. 0.7. What is the ratio of the Debt(current US$) in Jordan in 1977 to that in 1978?
Keep it short and to the point. 0.71. What is the ratio of the Debt(current US$) in Mexico in 1977 to that in 1978?
Ensure brevity in your answer.  0.72. What is the ratio of the Debt(current US$) of Lower middle income in 1977 to that in 1979?
Your answer should be compact. 0.69. What is the ratio of the Debt(current US$) in El Salvador in 1977 to that in 1979?
Ensure brevity in your answer.  0.68. What is the ratio of the Debt(current US$) of Jordan in 1977 to that in 1979?
Make the answer very short. 0.64. What is the ratio of the Debt(current US$) of Mexico in 1977 to that in 1979?
Keep it short and to the point. 0.67. What is the ratio of the Debt(current US$) in Lower middle income in 1977 to that in 1980?
Your answer should be very brief. 0.6. What is the ratio of the Debt(current US$) of El Salvador in 1977 to that in 1980?
Provide a succinct answer. 0.48. What is the ratio of the Debt(current US$) of Jordan in 1977 to that in 1980?
Keep it short and to the point. 0.46. What is the ratio of the Debt(current US$) in Mexico in 1977 to that in 1980?
Provide a short and direct response. 0.49. What is the ratio of the Debt(current US$) of Lower middle income in 1977 to that in 1981?
Your response must be concise. 0.57. What is the ratio of the Debt(current US$) in El Salvador in 1977 to that in 1981?
Provide a short and direct response. 0.45. What is the ratio of the Debt(current US$) in Jordan in 1977 to that in 1981?
Offer a terse response. 0.55. What is the ratio of the Debt(current US$) in Mexico in 1977 to that in 1981?
Offer a terse response. 0.4. What is the ratio of the Debt(current US$) of Lower middle income in 1977 to that in 1982?
Keep it short and to the point. 0.55. What is the ratio of the Debt(current US$) of El Salvador in 1977 to that in 1982?
Offer a terse response. 0.38. What is the ratio of the Debt(current US$) of Jordan in 1977 to that in 1982?
Give a very brief answer. 0.65. What is the ratio of the Debt(current US$) of Mexico in 1977 to that in 1982?
Offer a very short reply. 0.33. What is the ratio of the Debt(current US$) in Lower middle income in 1977 to that in 1983?
Offer a terse response. 0.54. What is the ratio of the Debt(current US$) of El Salvador in 1977 to that in 1983?
Give a very brief answer. 0.52. What is the ratio of the Debt(current US$) of Jordan in 1977 to that in 1983?
Your response must be concise. 0.67. What is the ratio of the Debt(current US$) in Mexico in 1977 to that in 1983?
Ensure brevity in your answer.  0.29. What is the ratio of the Debt(current US$) in Lower middle income in 1978 to that in 1979?
Give a very brief answer. 0.84. What is the ratio of the Debt(current US$) of El Salvador in 1978 to that in 1979?
Ensure brevity in your answer.  0.97. What is the ratio of the Debt(current US$) of Jordan in 1978 to that in 1979?
Offer a terse response. 0.9. What is the ratio of the Debt(current US$) of Mexico in 1978 to that in 1979?
Provide a succinct answer. 0.93. What is the ratio of the Debt(current US$) in Lower middle income in 1978 to that in 1980?
Keep it short and to the point. 0.73. What is the ratio of the Debt(current US$) of El Salvador in 1978 to that in 1980?
Give a very brief answer. 0.68. What is the ratio of the Debt(current US$) of Jordan in 1978 to that in 1980?
Offer a terse response. 0.64. What is the ratio of the Debt(current US$) of Mexico in 1978 to that in 1980?
Your response must be concise. 0.69. What is the ratio of the Debt(current US$) of Lower middle income in 1978 to that in 1981?
Your answer should be very brief. 0.69. What is the ratio of the Debt(current US$) in El Salvador in 1978 to that in 1981?
Offer a very short reply. 0.64. What is the ratio of the Debt(current US$) of Jordan in 1978 to that in 1981?
Provide a succinct answer. 0.78. What is the ratio of the Debt(current US$) in Mexico in 1978 to that in 1981?
Your response must be concise. 0.56. What is the ratio of the Debt(current US$) of Lower middle income in 1978 to that in 1982?
Make the answer very short. 0.67. What is the ratio of the Debt(current US$) of El Salvador in 1978 to that in 1982?
Your answer should be very brief. 0.54. What is the ratio of the Debt(current US$) of Jordan in 1978 to that in 1982?
Your answer should be very brief. 0.91. What is the ratio of the Debt(current US$) of Mexico in 1978 to that in 1982?
Your answer should be very brief. 0.45. What is the ratio of the Debt(current US$) of Lower middle income in 1978 to that in 1983?
Offer a terse response. 0.66. What is the ratio of the Debt(current US$) of El Salvador in 1978 to that in 1983?
Provide a short and direct response. 0.75. What is the ratio of the Debt(current US$) in Jordan in 1978 to that in 1983?
Provide a succinct answer. 0.93. What is the ratio of the Debt(current US$) in Mexico in 1978 to that in 1983?
Offer a terse response. 0.4. What is the ratio of the Debt(current US$) in Lower middle income in 1979 to that in 1980?
Provide a succinct answer. 0.87. What is the ratio of the Debt(current US$) of El Salvador in 1979 to that in 1980?
Provide a succinct answer. 0.7. What is the ratio of the Debt(current US$) in Jordan in 1979 to that in 1980?
Your answer should be very brief. 0.71. What is the ratio of the Debt(current US$) of Mexico in 1979 to that in 1980?
Your answer should be very brief. 0.73. What is the ratio of the Debt(current US$) of Lower middle income in 1979 to that in 1981?
Keep it short and to the point. 0.82. What is the ratio of the Debt(current US$) of El Salvador in 1979 to that in 1981?
Ensure brevity in your answer.  0.66. What is the ratio of the Debt(current US$) of Jordan in 1979 to that in 1981?
Give a very brief answer. 0.86. What is the ratio of the Debt(current US$) in Mexico in 1979 to that in 1981?
Provide a succinct answer. 0.6. What is the ratio of the Debt(current US$) in Lower middle income in 1979 to that in 1982?
Your answer should be compact. 0.8. What is the ratio of the Debt(current US$) in El Salvador in 1979 to that in 1982?
Your answer should be very brief. 0.55. What is the ratio of the Debt(current US$) in Jordan in 1979 to that in 1982?
Provide a short and direct response. 1.02. What is the ratio of the Debt(current US$) of Mexico in 1979 to that in 1982?
Provide a short and direct response. 0.48. What is the ratio of the Debt(current US$) in Lower middle income in 1979 to that in 1983?
Offer a very short reply. 0.78. What is the ratio of the Debt(current US$) in El Salvador in 1979 to that in 1983?
Your response must be concise. 0.77. What is the ratio of the Debt(current US$) in Jordan in 1979 to that in 1983?
Your answer should be compact. 1.04. What is the ratio of the Debt(current US$) in Mexico in 1979 to that in 1983?
Your response must be concise. 0.42. What is the ratio of the Debt(current US$) of Lower middle income in 1980 to that in 1981?
Your response must be concise. 0.94. What is the ratio of the Debt(current US$) of Jordan in 1980 to that in 1981?
Give a very brief answer. 1.21. What is the ratio of the Debt(current US$) in Mexico in 1980 to that in 1981?
Provide a short and direct response. 0.81. What is the ratio of the Debt(current US$) of Lower middle income in 1980 to that in 1982?
Offer a terse response. 0.92. What is the ratio of the Debt(current US$) in El Salvador in 1980 to that in 1982?
Your response must be concise. 0.79. What is the ratio of the Debt(current US$) of Jordan in 1980 to that in 1982?
Provide a short and direct response. 1.43. What is the ratio of the Debt(current US$) in Mexico in 1980 to that in 1982?
Offer a terse response. 0.66. What is the ratio of the Debt(current US$) of Lower middle income in 1980 to that in 1983?
Provide a succinct answer. 0.9. What is the ratio of the Debt(current US$) in El Salvador in 1980 to that in 1983?
Provide a short and direct response. 1.1. What is the ratio of the Debt(current US$) in Jordan in 1980 to that in 1983?
Your answer should be compact. 1.46. What is the ratio of the Debt(current US$) in Mexico in 1980 to that in 1983?
Offer a terse response. 0.58. What is the ratio of the Debt(current US$) in Lower middle income in 1981 to that in 1982?
Provide a succinct answer. 0.97. What is the ratio of the Debt(current US$) of El Salvador in 1981 to that in 1982?
Keep it short and to the point. 0.83. What is the ratio of the Debt(current US$) in Jordan in 1981 to that in 1982?
Your answer should be very brief. 1.18. What is the ratio of the Debt(current US$) in Mexico in 1981 to that in 1982?
Offer a very short reply. 0.81. What is the ratio of the Debt(current US$) of Lower middle income in 1981 to that in 1983?
Offer a very short reply. 0.95. What is the ratio of the Debt(current US$) of El Salvador in 1981 to that in 1983?
Ensure brevity in your answer.  1.16. What is the ratio of the Debt(current US$) in Jordan in 1981 to that in 1983?
Keep it short and to the point. 1.2. What is the ratio of the Debt(current US$) of Mexico in 1981 to that in 1983?
Your response must be concise. 0.71. What is the ratio of the Debt(current US$) of Lower middle income in 1982 to that in 1983?
Offer a very short reply. 0.98. What is the ratio of the Debt(current US$) of El Salvador in 1982 to that in 1983?
Keep it short and to the point. 1.39. What is the ratio of the Debt(current US$) of Jordan in 1982 to that in 1983?
Ensure brevity in your answer.  1.02. What is the ratio of the Debt(current US$) of Mexico in 1982 to that in 1983?
Keep it short and to the point. 0.88. What is the difference between the highest and the second highest Debt(current US$) in Lower middle income?
Your answer should be very brief. 9.38e+08. What is the difference between the highest and the second highest Debt(current US$) in El Salvador?
Keep it short and to the point. 8.48e+07. What is the difference between the highest and the second highest Debt(current US$) in Jordan?
Make the answer very short. 2.00e+08. What is the difference between the highest and the second highest Debt(current US$) of Mexico?
Your response must be concise. 6.25e+08. What is the difference between the highest and the lowest Debt(current US$) of Lower middle income?
Your answer should be compact. 2.60e+1. What is the difference between the highest and the lowest Debt(current US$) of El Salvador?
Make the answer very short. 3.18e+08. What is the difference between the highest and the lowest Debt(current US$) in Jordan?
Provide a succinct answer. 7.68e+08. What is the difference between the highest and the lowest Debt(current US$) of Mexico?
Your response must be concise. 3.72e+09. 